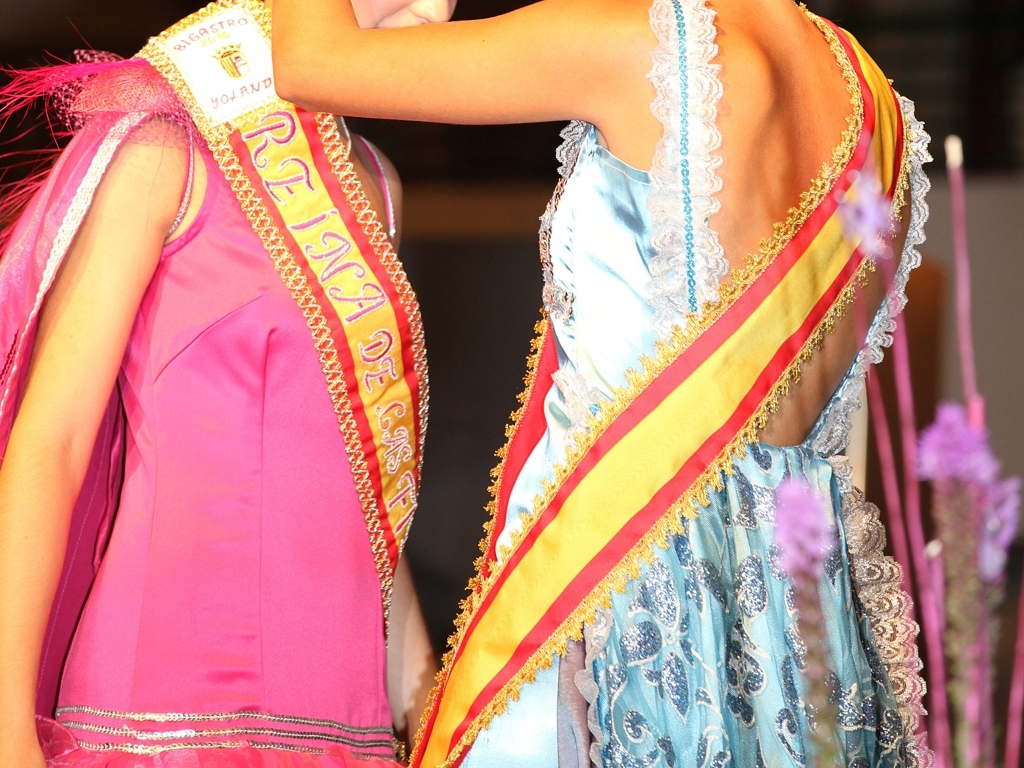Can you describe the attire showcased in the image? The image highlights elaborate evening gowns with intricate detailing. The attire is formal, likely worn for an event or a pageant, indicated by the sashes that often signify participation in or achievement at such affairs. What can you deduce about the event they might be attending from their attire? Given the sashes adorned with text and the formal nature of the gowns, it is plausible that the individuals are part of a pageant or ceremony that celebrates cultural, regional, or organizational representation. 